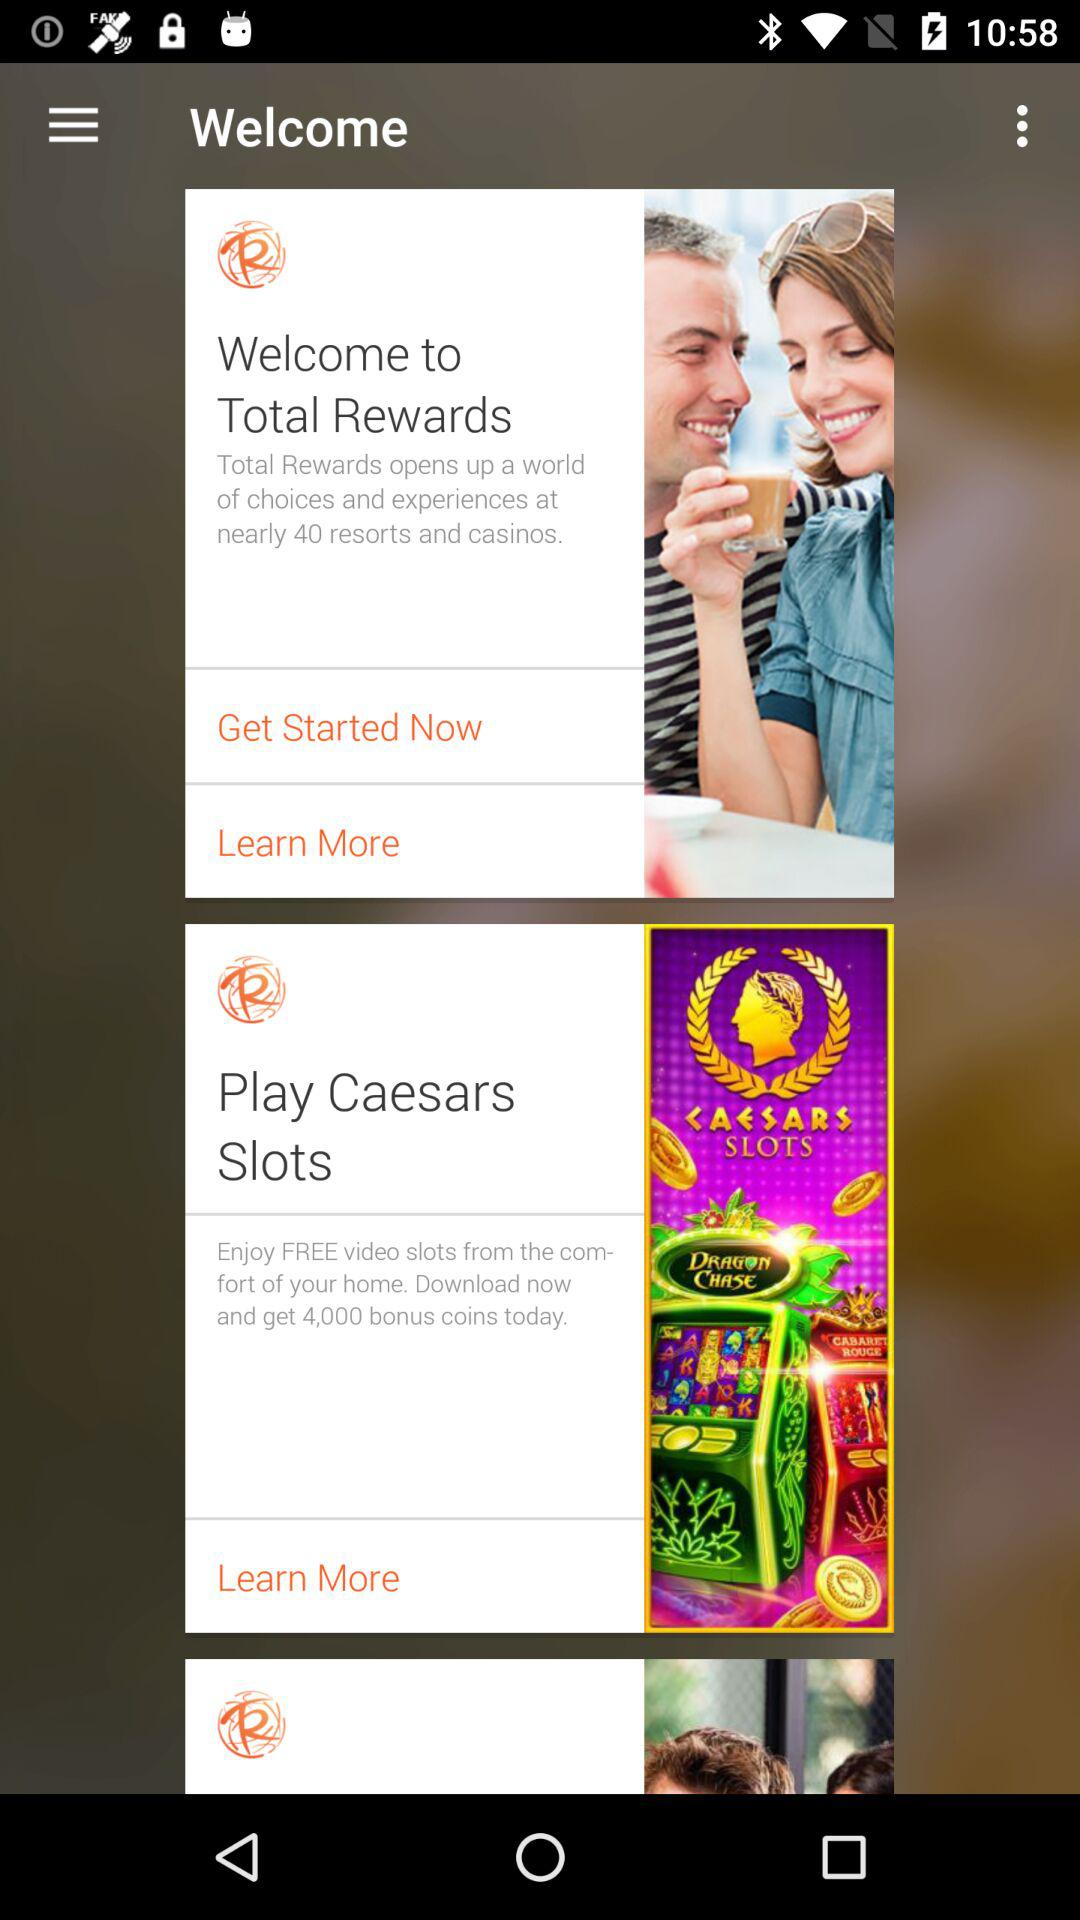What is the bonus coins? The bonus coins is 4000. 